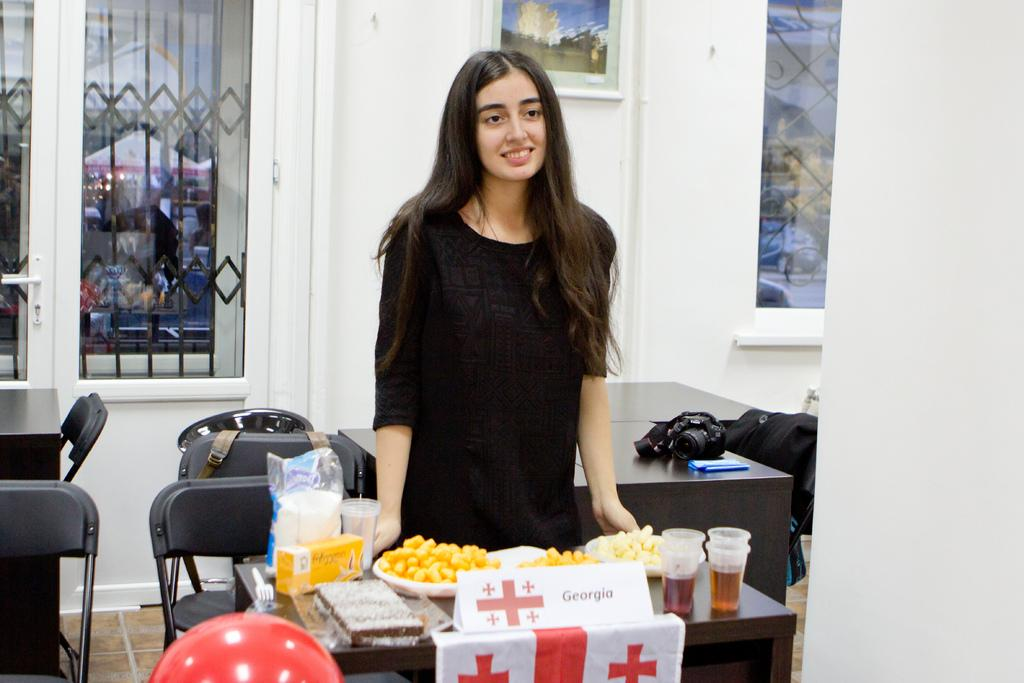Who is the main subject in the image? There is a girl in the image. What is the girl doing in the image? The girl is standing at a table. What can be found on the table in the image? There are eatables on the table. What type of beast can be seen in the girl's eye in the image? There is no beast visible in the girl's eye in the image. How many worms are crawling on the table in the image? There are no worms present on the table in the image. 